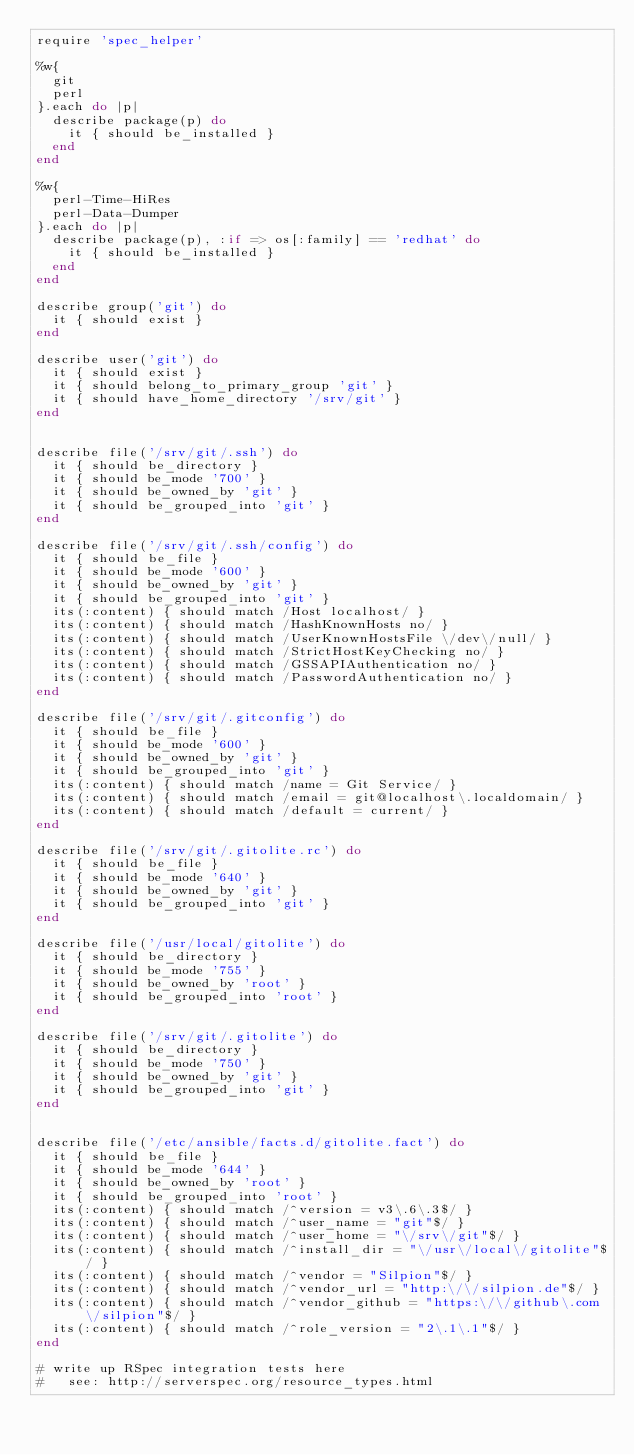<code> <loc_0><loc_0><loc_500><loc_500><_Ruby_>require 'spec_helper'

%w{
  git
  perl
}.each do |p|
  describe package(p) do
    it { should be_installed }
  end
end

%w{
  perl-Time-HiRes
  perl-Data-Dumper
}.each do |p|
  describe package(p), :if => os[:family] == 'redhat' do
    it { should be_installed }
  end
end

describe group('git') do
  it { should exist }
end

describe user('git') do
  it { should exist }
  it { should belong_to_primary_group 'git' }
  it { should have_home_directory '/srv/git' }
end


describe file('/srv/git/.ssh') do
  it { should be_directory }
  it { should be_mode '700' }
  it { should be_owned_by 'git' }
  it { should be_grouped_into 'git' }
end

describe file('/srv/git/.ssh/config') do
  it { should be_file }
  it { should be_mode '600' }
  it { should be_owned_by 'git' }
  it { should be_grouped_into 'git' }
  its(:content) { should match /Host localhost/ }
  its(:content) { should match /HashKnownHosts no/ }
  its(:content) { should match /UserKnownHostsFile \/dev\/null/ }
  its(:content) { should match /StrictHostKeyChecking no/ }
  its(:content) { should match /GSSAPIAuthentication no/ }
  its(:content) { should match /PasswordAuthentication no/ }
end

describe file('/srv/git/.gitconfig') do
  it { should be_file }
  it { should be_mode '600' }
  it { should be_owned_by 'git' }
  it { should be_grouped_into 'git' }
  its(:content) { should match /name = Git Service/ }
  its(:content) { should match /email = git@localhost\.localdomain/ }
  its(:content) { should match /default = current/ }
end

describe file('/srv/git/.gitolite.rc') do
  it { should be_file }
  it { should be_mode '640' }
  it { should be_owned_by 'git' }
  it { should be_grouped_into 'git' }
end

describe file('/usr/local/gitolite') do
  it { should be_directory }
  it { should be_mode '755' }
  it { should be_owned_by 'root' }
  it { should be_grouped_into 'root' }
end

describe file('/srv/git/.gitolite') do
  it { should be_directory }
  it { should be_mode '750' }
  it { should be_owned_by 'git' }
  it { should be_grouped_into 'git' }
end


describe file('/etc/ansible/facts.d/gitolite.fact') do
  it { should be_file }
  it { should be_mode '644' }
  it { should be_owned_by 'root' }
  it { should be_grouped_into 'root' }
  its(:content) { should match /^version = v3\.6\.3$/ }
  its(:content) { should match /^user_name = "git"$/ }
  its(:content) { should match /^user_home = "\/srv\/git"$/ }
  its(:content) { should match /^install_dir = "\/usr\/local\/gitolite"$/ }
  its(:content) { should match /^vendor = "Silpion"$/ }
  its(:content) { should match /^vendor_url = "http:\/\/silpion.de"$/ }
  its(:content) { should match /^vendor_github = "https:\/\/github\.com\/silpion"$/ }
  its(:content) { should match /^role_version = "2\.1\.1"$/ }
end

# write up RSpec integration tests here
#   see: http://serverspec.org/resource_types.html
</code> 